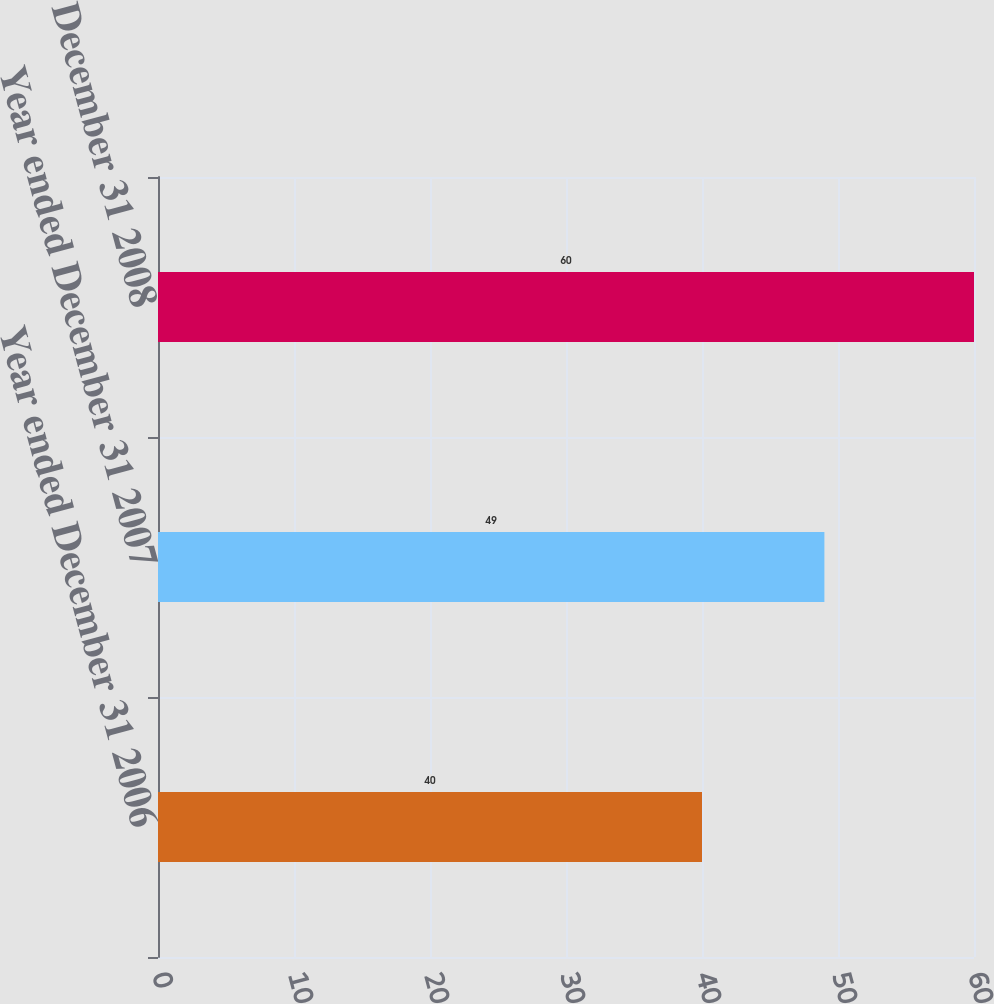Convert chart. <chart><loc_0><loc_0><loc_500><loc_500><bar_chart><fcel>Year ended December 31 2006<fcel>Year ended December 31 2007<fcel>Year ended December 31 2008<nl><fcel>40<fcel>49<fcel>60<nl></chart> 